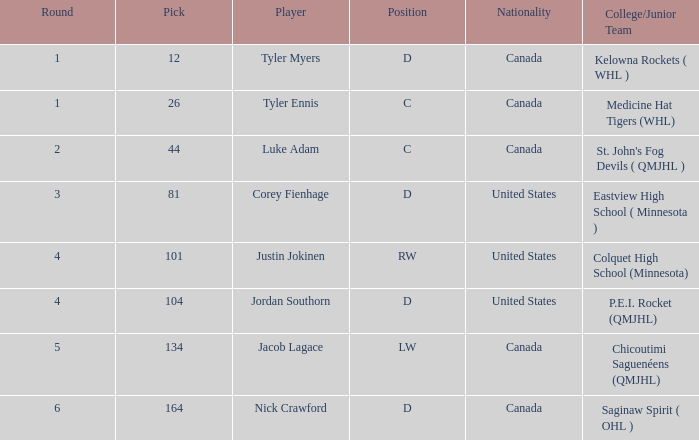What is the median round of the rw position competitor from the united states? 4.0. 